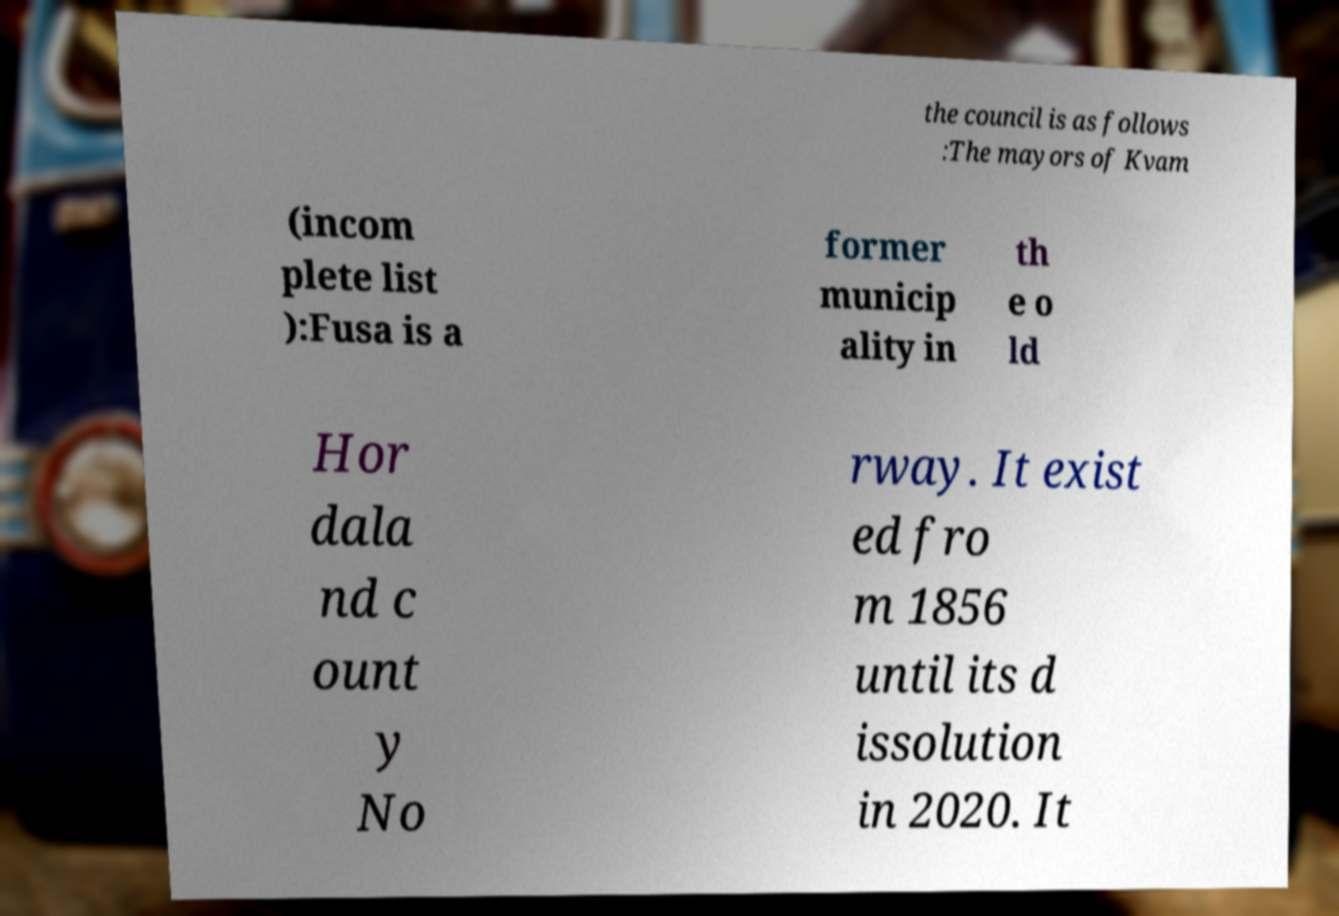Could you assist in decoding the text presented in this image and type it out clearly? the council is as follows :The mayors of Kvam (incom plete list ):Fusa is a former municip ality in th e o ld Hor dala nd c ount y No rway. It exist ed fro m 1856 until its d issolution in 2020. It 